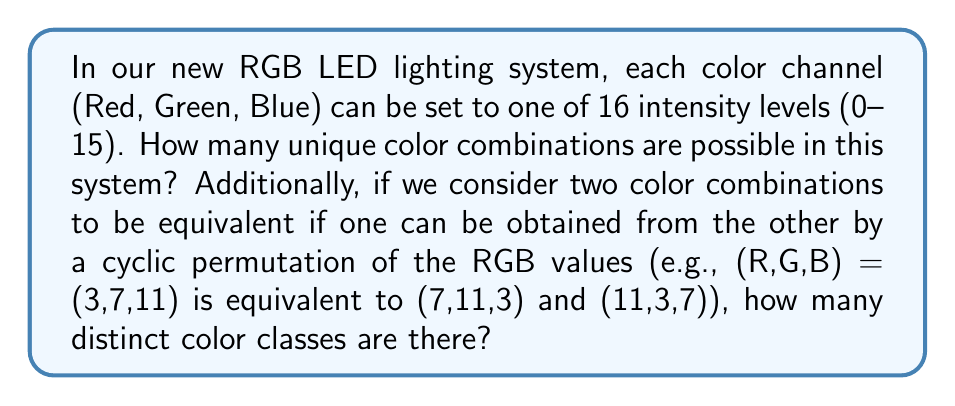Teach me how to tackle this problem. Let's approach this problem step by step:

1) First, let's calculate the total number of unique color combinations:
   - Each color channel has 16 possible values (0-15)
   - We have 3 independent channels (R, G, B)
   - The total number of combinations is therefore $16^3 = 4096$

2) Now, let's consider the color classes under cyclic permutation:
   - Each color combination (R,G,B) can be cyclically permuted in 3 ways: (R,G,B), (G,B,R), (B,R,G)
   - However, some combinations may have fewer than 3 unique permutations:
     a) If all three values are the same, e.g., (5,5,5), there's only 1 unique permutation
     b) If two values are the same and one is different, e.g., (5,5,7), there are only 3 unique permutations
     c) If all three values are different, there are 3 unique permutations

3) To count the distinct color classes:
   a) Combinations with all values the same: $16$ (one for each intensity level)
   b) Combinations with two values the same:
      - Choose the repeated value: 16 ways
      - Choose the position for the different value: 3 ways
      - Choose the different value: 15 ways (can't be the same as the repeated value)
      - Total: $16 \times 3 \times 15 = 720$
   c) Combinations with all values different:
      - Total combinations minus those with repeated values: $4096 - 16 - 720 = 3360$
      - Each of these forms a class of 3, so divide by 3: $3360 / 3 = 1120$

4) The total number of distinct color classes is the sum of (a), (b), and (c):
   $16 + 720 + 1120 = 1856$
Answer: There are 4096 unique color combinations, and 1856 distinct color classes under cyclic permutation. 